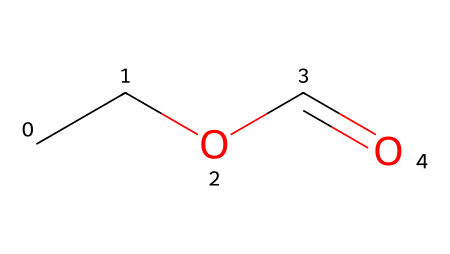What is the molecular formula of ethyl formate? To derive the molecular formula, we can interpret the SMILES representation (CCOC=O). The 'CC' indicates two carbon (C) atoms, 'O' after 'C' signifies the attachment of an oxygen (O) atom in an ester linkage, and 'C=O' shows another carbon with a double bonded oxygen (O). This gives us a total of 3 carbon (C) atoms, 6 hydrogen (H) atoms, and 2 oxygen (O) atoms, resulting in the formula C3H6O2.
Answer: C3H6O2 How many different types of atoms are present in ethyl formate? The SMILES representation shows three types of atoms: carbon (C), hydrogen (H), and oxygen (O). Counting these gives us 3 total types of atoms.
Answer: 3 What functional group is present in ethyl formate? The structure includes a carbonyl group (C=O) adjacent to an ether (C-O-C) linkage, indicating it contains an ester functional group. This is characteristic of esters formed from alcohols and carboxylic acids.
Answer: ester How many carbon atoms are in ethyl formate? Observing the SMILES 'CCOC=O', we note that 'CC' represents two carbon atoms, and one more carbon is involved in the carbonyl group, resulting in a total of three carbon atoms.
Answer: 3 What is the common use of ethyl formate? Ethyl formate is commonly utilized as a flavoring agent and solvent in various applications, frequently found in food products or used in fragrances, thanks to its fruity aroma.
Answer: flavoring agent Is ethyl formate a saturated or unsaturated ester? The presence of a carbonyl group (C=O) indicates saturation of the alcohol portion while including carbon connectivity leads to the conclusion that it overall retains a saturated character with respect to carbon chains. However, due to the carbonyl, it retains properties of unsaturation. Hence, it is classified as unsaturated.
Answer: unsaturated 